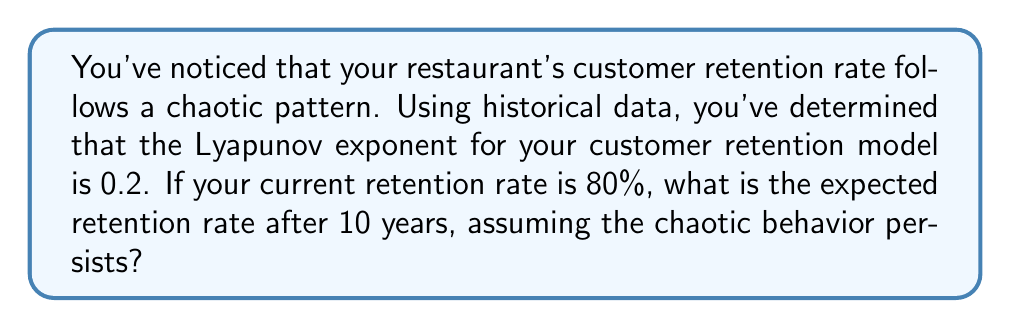Solve this math problem. To solve this problem, we'll use the properties of Lyapunov exponents in chaos theory:

1. The Lyapunov exponent (λ) measures the rate of divergence of nearby trajectories in a dynamical system. A positive λ indicates chaos.

2. In a chaotic system, the divergence of trajectories grows exponentially with time, following the equation:

   $$d(t) = d_0 e^{\lambda t}$$

   where $d(t)$ is the divergence at time $t$, $d_0$ is the initial divergence, and $\lambda$ is the Lyapunov exponent.

3. In our case, we're interested in the divergence from the initial retention rate. Let's consider the complement of the retention rate (i.e., the loss rate) as our measure of divergence.

   Initial retention rate = 80%
   Initial loss rate = 20% = 0.2

4. We'll use this as our $d_0$. The time period is 10 years, and λ = 0.2.

5. Plugging these values into the equation:

   $$d(10) = 0.2 e^{0.2 * 10} = 0.2 e^2 \approx 1.4778$$

6. This result represents the expected loss rate after 10 years. To get the retention rate, we subtract this from 1:

   Retention rate = 1 - 1.4778 = -0.4778

7. However, a negative retention rate doesn't make sense in real-world terms. This indicates that the chaotic behavior has led to a complete loss of the original customer base and potentially negative word-of-mouth effects.

8. In practical terms, we would interpret this as a retention rate of 0%, meaning all original customers have been lost over the 10-year period.
Answer: 0% 